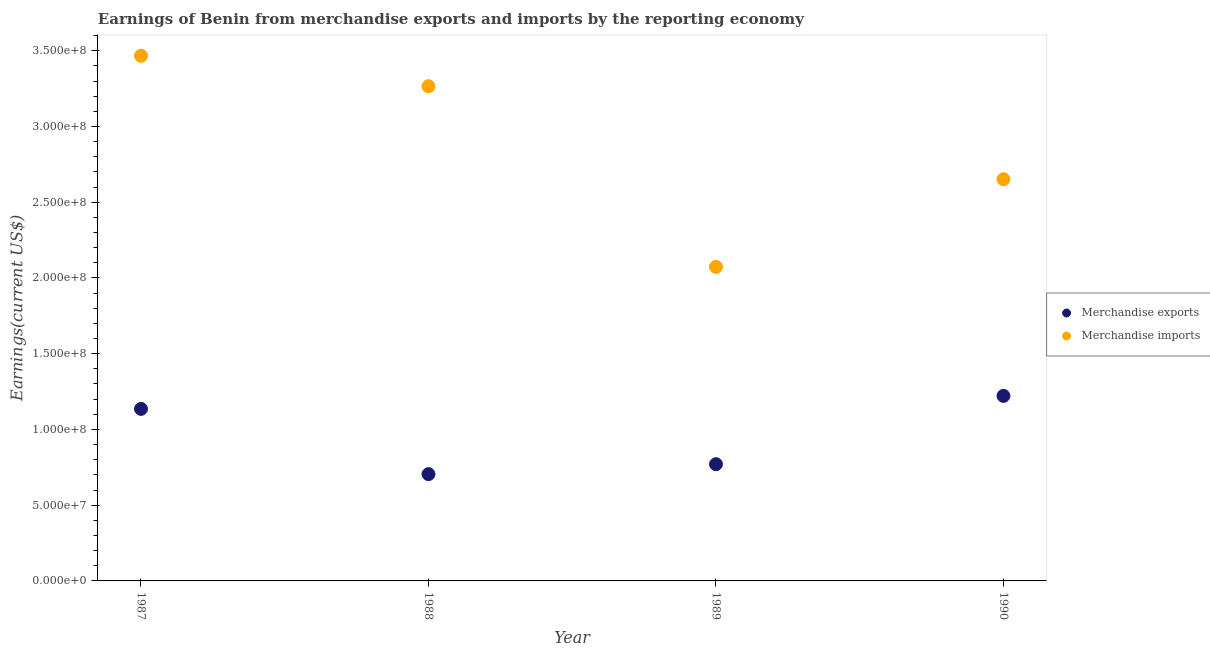What is the earnings from merchandise exports in 1990?
Your answer should be compact. 1.22e+08. Across all years, what is the maximum earnings from merchandise imports?
Offer a very short reply. 3.47e+08. Across all years, what is the minimum earnings from merchandise imports?
Give a very brief answer. 2.07e+08. In which year was the earnings from merchandise imports minimum?
Give a very brief answer. 1989. What is the total earnings from merchandise imports in the graph?
Ensure brevity in your answer.  1.15e+09. What is the difference between the earnings from merchandise exports in 1988 and that in 1989?
Your answer should be very brief. -6.56e+06. What is the difference between the earnings from merchandise imports in 1989 and the earnings from merchandise exports in 1990?
Provide a short and direct response. 8.52e+07. What is the average earnings from merchandise imports per year?
Provide a succinct answer. 2.86e+08. In the year 1987, what is the difference between the earnings from merchandise exports and earnings from merchandise imports?
Provide a short and direct response. -2.33e+08. In how many years, is the earnings from merchandise exports greater than 310000000 US$?
Make the answer very short. 0. What is the ratio of the earnings from merchandise imports in 1988 to that in 1989?
Your answer should be compact. 1.58. Is the earnings from merchandise exports in 1987 less than that in 1988?
Your answer should be very brief. No. What is the difference between the highest and the second highest earnings from merchandise exports?
Your answer should be compact. 8.58e+06. What is the difference between the highest and the lowest earnings from merchandise imports?
Provide a short and direct response. 1.39e+08. How many dotlines are there?
Your answer should be compact. 2. How many years are there in the graph?
Your answer should be very brief. 4. What is the difference between two consecutive major ticks on the Y-axis?
Keep it short and to the point. 5.00e+07. Does the graph contain any zero values?
Your answer should be very brief. No. How are the legend labels stacked?
Offer a very short reply. Vertical. What is the title of the graph?
Ensure brevity in your answer.  Earnings of Benin from merchandise exports and imports by the reporting economy. What is the label or title of the X-axis?
Offer a very short reply. Year. What is the label or title of the Y-axis?
Offer a terse response. Earnings(current US$). What is the Earnings(current US$) of Merchandise exports in 1987?
Provide a succinct answer. 1.14e+08. What is the Earnings(current US$) of Merchandise imports in 1987?
Make the answer very short. 3.47e+08. What is the Earnings(current US$) in Merchandise exports in 1988?
Make the answer very short. 7.05e+07. What is the Earnings(current US$) of Merchandise imports in 1988?
Give a very brief answer. 3.27e+08. What is the Earnings(current US$) in Merchandise exports in 1989?
Keep it short and to the point. 7.70e+07. What is the Earnings(current US$) of Merchandise imports in 1989?
Your answer should be compact. 2.07e+08. What is the Earnings(current US$) in Merchandise exports in 1990?
Ensure brevity in your answer.  1.22e+08. What is the Earnings(current US$) in Merchandise imports in 1990?
Your answer should be compact. 2.65e+08. Across all years, what is the maximum Earnings(current US$) in Merchandise exports?
Make the answer very short. 1.22e+08. Across all years, what is the maximum Earnings(current US$) in Merchandise imports?
Make the answer very short. 3.47e+08. Across all years, what is the minimum Earnings(current US$) of Merchandise exports?
Offer a very short reply. 7.05e+07. Across all years, what is the minimum Earnings(current US$) of Merchandise imports?
Offer a very short reply. 2.07e+08. What is the total Earnings(current US$) of Merchandise exports in the graph?
Your answer should be very brief. 3.83e+08. What is the total Earnings(current US$) in Merchandise imports in the graph?
Your answer should be compact. 1.15e+09. What is the difference between the Earnings(current US$) of Merchandise exports in 1987 and that in 1988?
Your answer should be very brief. 4.31e+07. What is the difference between the Earnings(current US$) in Merchandise imports in 1987 and that in 1988?
Give a very brief answer. 2.01e+07. What is the difference between the Earnings(current US$) in Merchandise exports in 1987 and that in 1989?
Make the answer very short. 3.65e+07. What is the difference between the Earnings(current US$) of Merchandise imports in 1987 and that in 1989?
Your answer should be compact. 1.39e+08. What is the difference between the Earnings(current US$) of Merchandise exports in 1987 and that in 1990?
Your answer should be very brief. -8.58e+06. What is the difference between the Earnings(current US$) in Merchandise imports in 1987 and that in 1990?
Offer a very short reply. 8.15e+07. What is the difference between the Earnings(current US$) in Merchandise exports in 1988 and that in 1989?
Your response must be concise. -6.56e+06. What is the difference between the Earnings(current US$) of Merchandise imports in 1988 and that in 1989?
Make the answer very short. 1.19e+08. What is the difference between the Earnings(current US$) of Merchandise exports in 1988 and that in 1990?
Give a very brief answer. -5.17e+07. What is the difference between the Earnings(current US$) in Merchandise imports in 1988 and that in 1990?
Keep it short and to the point. 6.14e+07. What is the difference between the Earnings(current US$) in Merchandise exports in 1989 and that in 1990?
Keep it short and to the point. -4.51e+07. What is the difference between the Earnings(current US$) of Merchandise imports in 1989 and that in 1990?
Provide a short and direct response. -5.78e+07. What is the difference between the Earnings(current US$) of Merchandise exports in 1987 and the Earnings(current US$) of Merchandise imports in 1988?
Make the answer very short. -2.13e+08. What is the difference between the Earnings(current US$) in Merchandise exports in 1987 and the Earnings(current US$) in Merchandise imports in 1989?
Your response must be concise. -9.37e+07. What is the difference between the Earnings(current US$) of Merchandise exports in 1987 and the Earnings(current US$) of Merchandise imports in 1990?
Make the answer very short. -1.52e+08. What is the difference between the Earnings(current US$) of Merchandise exports in 1988 and the Earnings(current US$) of Merchandise imports in 1989?
Your answer should be compact. -1.37e+08. What is the difference between the Earnings(current US$) of Merchandise exports in 1988 and the Earnings(current US$) of Merchandise imports in 1990?
Offer a very short reply. -1.95e+08. What is the difference between the Earnings(current US$) of Merchandise exports in 1989 and the Earnings(current US$) of Merchandise imports in 1990?
Keep it short and to the point. -1.88e+08. What is the average Earnings(current US$) in Merchandise exports per year?
Make the answer very short. 9.58e+07. What is the average Earnings(current US$) in Merchandise imports per year?
Your answer should be compact. 2.86e+08. In the year 1987, what is the difference between the Earnings(current US$) of Merchandise exports and Earnings(current US$) of Merchandise imports?
Your response must be concise. -2.33e+08. In the year 1988, what is the difference between the Earnings(current US$) of Merchandise exports and Earnings(current US$) of Merchandise imports?
Your answer should be compact. -2.56e+08. In the year 1989, what is the difference between the Earnings(current US$) of Merchandise exports and Earnings(current US$) of Merchandise imports?
Your response must be concise. -1.30e+08. In the year 1990, what is the difference between the Earnings(current US$) in Merchandise exports and Earnings(current US$) in Merchandise imports?
Ensure brevity in your answer.  -1.43e+08. What is the ratio of the Earnings(current US$) of Merchandise exports in 1987 to that in 1988?
Offer a very short reply. 1.61. What is the ratio of the Earnings(current US$) of Merchandise imports in 1987 to that in 1988?
Your answer should be very brief. 1.06. What is the ratio of the Earnings(current US$) of Merchandise exports in 1987 to that in 1989?
Ensure brevity in your answer.  1.47. What is the ratio of the Earnings(current US$) of Merchandise imports in 1987 to that in 1989?
Offer a very short reply. 1.67. What is the ratio of the Earnings(current US$) in Merchandise exports in 1987 to that in 1990?
Your answer should be compact. 0.93. What is the ratio of the Earnings(current US$) of Merchandise imports in 1987 to that in 1990?
Your response must be concise. 1.31. What is the ratio of the Earnings(current US$) of Merchandise exports in 1988 to that in 1989?
Keep it short and to the point. 0.91. What is the ratio of the Earnings(current US$) in Merchandise imports in 1988 to that in 1989?
Your answer should be very brief. 1.58. What is the ratio of the Earnings(current US$) of Merchandise exports in 1988 to that in 1990?
Provide a short and direct response. 0.58. What is the ratio of the Earnings(current US$) of Merchandise imports in 1988 to that in 1990?
Offer a terse response. 1.23. What is the ratio of the Earnings(current US$) in Merchandise exports in 1989 to that in 1990?
Make the answer very short. 0.63. What is the ratio of the Earnings(current US$) of Merchandise imports in 1989 to that in 1990?
Ensure brevity in your answer.  0.78. What is the difference between the highest and the second highest Earnings(current US$) in Merchandise exports?
Make the answer very short. 8.58e+06. What is the difference between the highest and the second highest Earnings(current US$) of Merchandise imports?
Offer a very short reply. 2.01e+07. What is the difference between the highest and the lowest Earnings(current US$) in Merchandise exports?
Offer a very short reply. 5.17e+07. What is the difference between the highest and the lowest Earnings(current US$) of Merchandise imports?
Ensure brevity in your answer.  1.39e+08. 